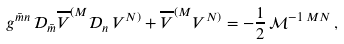<formula> <loc_0><loc_0><loc_500><loc_500>g ^ { \bar { m } n } \, \mathcal { D } _ { \bar { m } } \overline { V } ^ { ( M } \mathcal { D } _ { n } \, V ^ { N ) } + \overline { V } ^ { ( M } V ^ { N ) } = - \frac { 1 } { 2 } \, \mathcal { M } ^ { - 1 \, M N } \, ,</formula> 